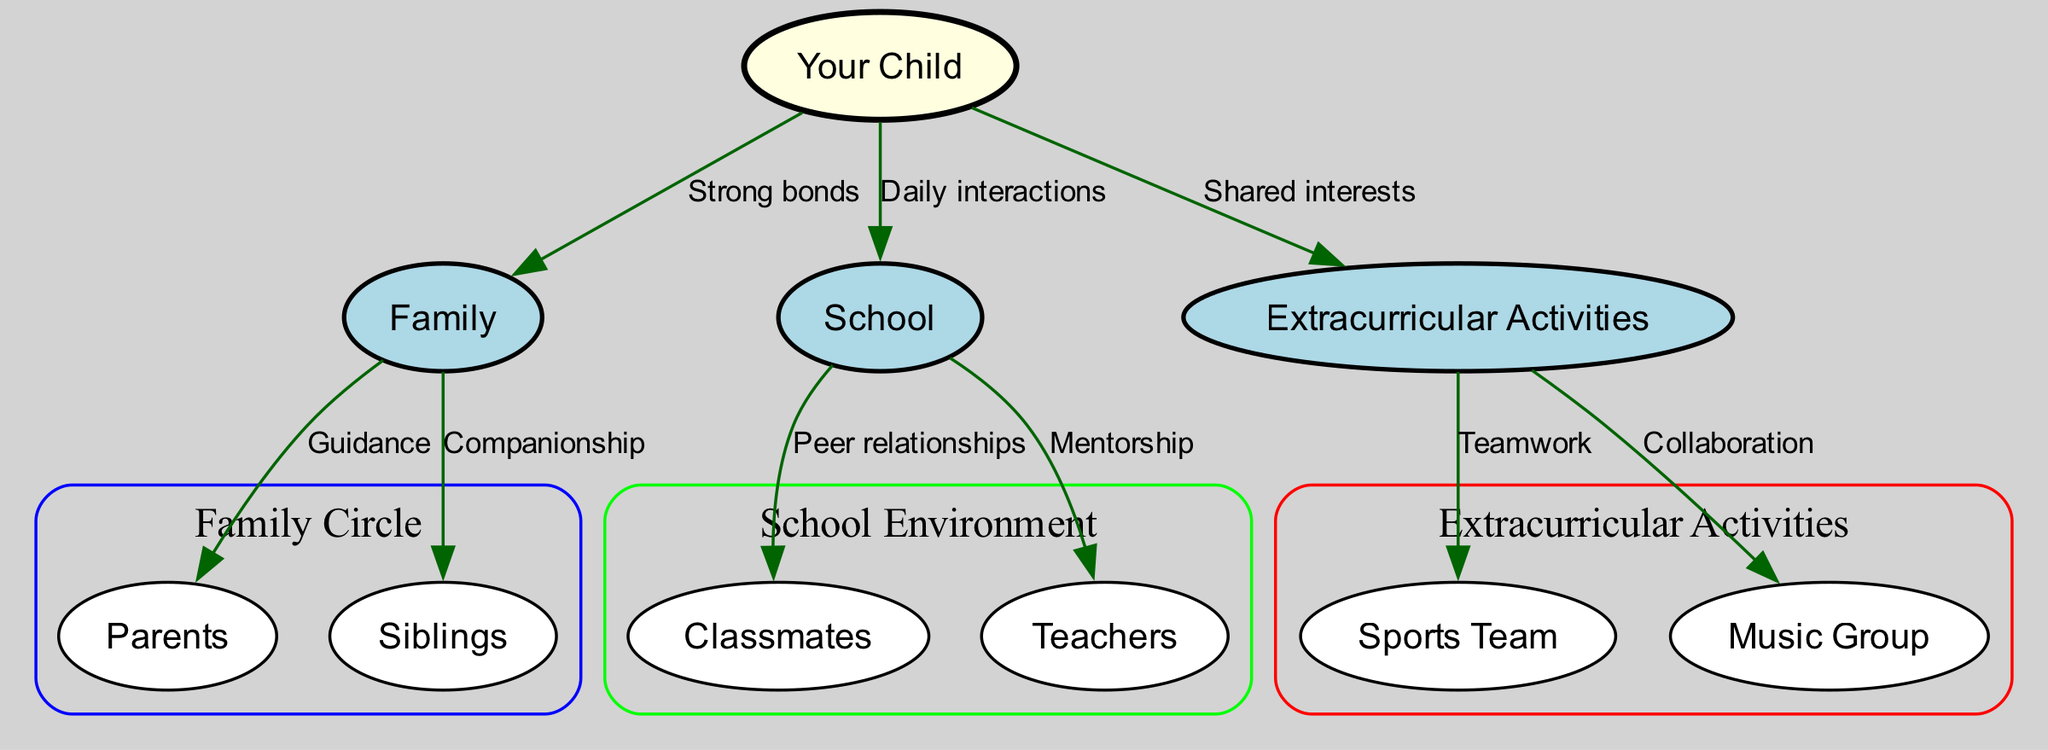What is the central node in the diagram? The central node represents "Your Child," which is the main focus of the social connections illustrated in the diagram. It is usually located in the center, connecting to various surrounding nodes.
Answer: Your Child How many nodes represent family members in the diagram? There are three nodes representing family members: "Parents," "Siblings," and the overarching "Family" node that connects them.
Answer: 3 What type of relationship exists between "Your Child" and "Family"? The edge between "Your Child" and "Family" is labeled "Strong bonds," indicating an intimate and supportive relationship fostering close connections.
Answer: Strong bonds How many edges connect "Your Child" to different environments? "Your Child" is connected to three different environments: "Family," "School," and "Extracurricular Activities," leading to a total of three edges originating from "Your Child."
Answer: 3 What is the importance of the "Teachers" node in the diagram? The "Teachers" node is important for providing "Mentorship" within the school environment, indicating a crucial role in the child's social and educational growth.
Answer: Mentorship Which two nodes are related by the label "Teamwork"? The "Sports Team" node is connected to "Extracurricular Activities" with the label "Teamwork," signifying a relationship based on collaboration in sports activities.
Answer: Sports Team and Extracurricular Activities What connects the "Classmates" to "School"? The connection between "Classmates" and "School" is labeled "Peer relationships," emphasizing the social dynamics and friendships among peers within the school environment.
Answer: Peer relationships Why are "Sports Team" and "Music Group" included in the diagram? These nodes represent different types of extracurricular activities in which "Your Child" can participate, showcasing shared interests and opportunities for friendships and social development.
Answer: Shared interests What is the relationship labeled between "Family" and "Siblings"? The edge between "Family" and "Siblings" is labeled "Companionship," indicating a close and supportive relationship among siblings within the family unit.
Answer: Companionship 